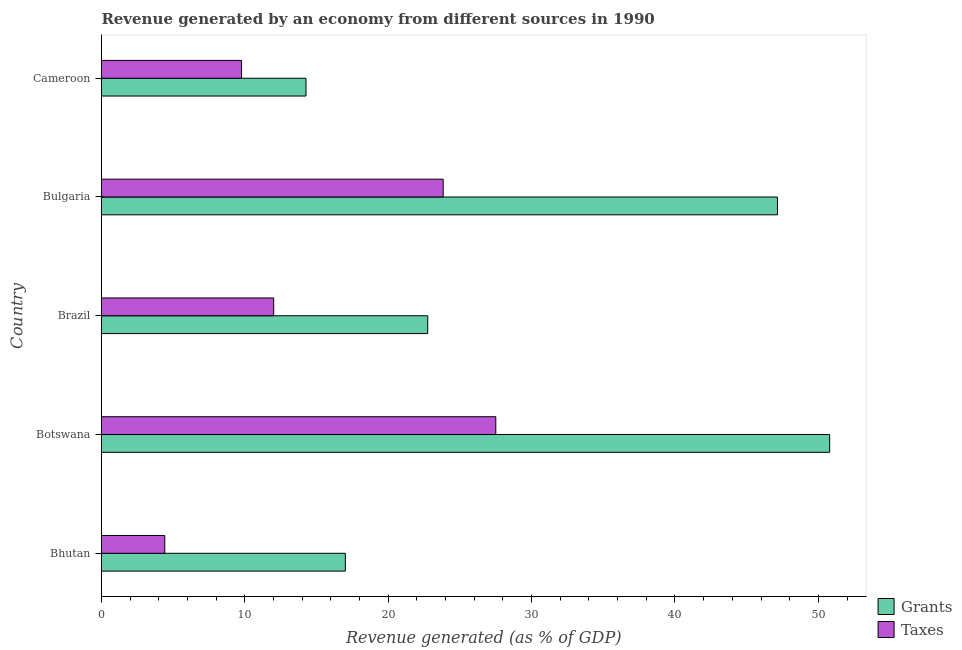How many different coloured bars are there?
Your response must be concise. 2. How many groups of bars are there?
Offer a terse response. 5. Are the number of bars per tick equal to the number of legend labels?
Ensure brevity in your answer.  Yes. How many bars are there on the 5th tick from the top?
Your answer should be compact. 2. What is the label of the 5th group of bars from the top?
Your response must be concise. Bhutan. What is the revenue generated by grants in Bhutan?
Make the answer very short. 17.01. Across all countries, what is the maximum revenue generated by taxes?
Offer a very short reply. 27.5. Across all countries, what is the minimum revenue generated by taxes?
Offer a terse response. 4.41. In which country was the revenue generated by grants maximum?
Provide a succinct answer. Botswana. In which country was the revenue generated by grants minimum?
Your response must be concise. Cameroon. What is the total revenue generated by taxes in the graph?
Your answer should be compact. 77.53. What is the difference between the revenue generated by grants in Botswana and that in Bulgaria?
Offer a terse response. 3.64. What is the difference between the revenue generated by grants in Bulgaria and the revenue generated by taxes in Brazil?
Provide a short and direct response. 35.14. What is the average revenue generated by taxes per country?
Your answer should be very brief. 15.51. What is the difference between the revenue generated by taxes and revenue generated by grants in Brazil?
Ensure brevity in your answer.  -10.74. What is the ratio of the revenue generated by taxes in Brazil to that in Bulgaria?
Your answer should be compact. 0.5. Is the revenue generated by taxes in Bhutan less than that in Cameroon?
Offer a very short reply. Yes. Is the difference between the revenue generated by grants in Bhutan and Bulgaria greater than the difference between the revenue generated by taxes in Bhutan and Bulgaria?
Provide a short and direct response. No. What is the difference between the highest and the second highest revenue generated by taxes?
Your answer should be compact. 3.67. What is the difference between the highest and the lowest revenue generated by grants?
Offer a very short reply. 36.53. In how many countries, is the revenue generated by grants greater than the average revenue generated by grants taken over all countries?
Your answer should be very brief. 2. What does the 2nd bar from the top in Cameroon represents?
Give a very brief answer. Grants. What does the 2nd bar from the bottom in Bulgaria represents?
Provide a short and direct response. Taxes. What is the difference between two consecutive major ticks on the X-axis?
Give a very brief answer. 10. Are the values on the major ticks of X-axis written in scientific E-notation?
Make the answer very short. No. Does the graph contain any zero values?
Make the answer very short. No. Does the graph contain grids?
Make the answer very short. No. What is the title of the graph?
Make the answer very short. Revenue generated by an economy from different sources in 1990. Does "Mineral" appear as one of the legend labels in the graph?
Offer a very short reply. No. What is the label or title of the X-axis?
Give a very brief answer. Revenue generated (as % of GDP). What is the label or title of the Y-axis?
Provide a succinct answer. Country. What is the Revenue generated (as % of GDP) of Grants in Bhutan?
Keep it short and to the point. 17.01. What is the Revenue generated (as % of GDP) in Taxes in Bhutan?
Your response must be concise. 4.41. What is the Revenue generated (as % of GDP) in Grants in Botswana?
Provide a short and direct response. 50.79. What is the Revenue generated (as % of GDP) in Taxes in Botswana?
Offer a terse response. 27.5. What is the Revenue generated (as % of GDP) of Grants in Brazil?
Your response must be concise. 22.75. What is the Revenue generated (as % of GDP) in Taxes in Brazil?
Your response must be concise. 12.01. What is the Revenue generated (as % of GDP) of Grants in Bulgaria?
Provide a short and direct response. 47.15. What is the Revenue generated (as % of GDP) of Taxes in Bulgaria?
Provide a short and direct response. 23.83. What is the Revenue generated (as % of GDP) of Grants in Cameroon?
Your response must be concise. 14.26. What is the Revenue generated (as % of GDP) of Taxes in Cameroon?
Your answer should be very brief. 9.77. Across all countries, what is the maximum Revenue generated (as % of GDP) of Grants?
Make the answer very short. 50.79. Across all countries, what is the maximum Revenue generated (as % of GDP) in Taxes?
Give a very brief answer. 27.5. Across all countries, what is the minimum Revenue generated (as % of GDP) of Grants?
Offer a terse response. 14.26. Across all countries, what is the minimum Revenue generated (as % of GDP) of Taxes?
Make the answer very short. 4.41. What is the total Revenue generated (as % of GDP) in Grants in the graph?
Your answer should be compact. 151.96. What is the total Revenue generated (as % of GDP) of Taxes in the graph?
Your answer should be compact. 77.53. What is the difference between the Revenue generated (as % of GDP) in Grants in Bhutan and that in Botswana?
Make the answer very short. -33.78. What is the difference between the Revenue generated (as % of GDP) of Taxes in Bhutan and that in Botswana?
Keep it short and to the point. -23.09. What is the difference between the Revenue generated (as % of GDP) in Grants in Bhutan and that in Brazil?
Make the answer very short. -5.74. What is the difference between the Revenue generated (as % of GDP) in Taxes in Bhutan and that in Brazil?
Provide a short and direct response. -7.6. What is the difference between the Revenue generated (as % of GDP) in Grants in Bhutan and that in Bulgaria?
Your response must be concise. -30.14. What is the difference between the Revenue generated (as % of GDP) in Taxes in Bhutan and that in Bulgaria?
Ensure brevity in your answer.  -19.42. What is the difference between the Revenue generated (as % of GDP) of Grants in Bhutan and that in Cameroon?
Give a very brief answer. 2.75. What is the difference between the Revenue generated (as % of GDP) of Taxes in Bhutan and that in Cameroon?
Your answer should be compact. -5.35. What is the difference between the Revenue generated (as % of GDP) of Grants in Botswana and that in Brazil?
Ensure brevity in your answer.  28.04. What is the difference between the Revenue generated (as % of GDP) in Taxes in Botswana and that in Brazil?
Offer a terse response. 15.49. What is the difference between the Revenue generated (as % of GDP) of Grants in Botswana and that in Bulgaria?
Make the answer very short. 3.64. What is the difference between the Revenue generated (as % of GDP) of Taxes in Botswana and that in Bulgaria?
Your response must be concise. 3.67. What is the difference between the Revenue generated (as % of GDP) of Grants in Botswana and that in Cameroon?
Keep it short and to the point. 36.53. What is the difference between the Revenue generated (as % of GDP) of Taxes in Botswana and that in Cameroon?
Provide a short and direct response. 17.73. What is the difference between the Revenue generated (as % of GDP) in Grants in Brazil and that in Bulgaria?
Offer a very short reply. -24.39. What is the difference between the Revenue generated (as % of GDP) of Taxes in Brazil and that in Bulgaria?
Provide a short and direct response. -11.82. What is the difference between the Revenue generated (as % of GDP) in Grants in Brazil and that in Cameroon?
Provide a short and direct response. 8.49. What is the difference between the Revenue generated (as % of GDP) of Taxes in Brazil and that in Cameroon?
Ensure brevity in your answer.  2.24. What is the difference between the Revenue generated (as % of GDP) of Grants in Bulgaria and that in Cameroon?
Keep it short and to the point. 32.88. What is the difference between the Revenue generated (as % of GDP) in Taxes in Bulgaria and that in Cameroon?
Your answer should be compact. 14.07. What is the difference between the Revenue generated (as % of GDP) in Grants in Bhutan and the Revenue generated (as % of GDP) in Taxes in Botswana?
Keep it short and to the point. -10.49. What is the difference between the Revenue generated (as % of GDP) in Grants in Bhutan and the Revenue generated (as % of GDP) in Taxes in Brazil?
Keep it short and to the point. 5. What is the difference between the Revenue generated (as % of GDP) of Grants in Bhutan and the Revenue generated (as % of GDP) of Taxes in Bulgaria?
Provide a short and direct response. -6.83. What is the difference between the Revenue generated (as % of GDP) of Grants in Bhutan and the Revenue generated (as % of GDP) of Taxes in Cameroon?
Make the answer very short. 7.24. What is the difference between the Revenue generated (as % of GDP) of Grants in Botswana and the Revenue generated (as % of GDP) of Taxes in Brazil?
Make the answer very short. 38.78. What is the difference between the Revenue generated (as % of GDP) of Grants in Botswana and the Revenue generated (as % of GDP) of Taxes in Bulgaria?
Your answer should be compact. 26.95. What is the difference between the Revenue generated (as % of GDP) in Grants in Botswana and the Revenue generated (as % of GDP) in Taxes in Cameroon?
Your answer should be very brief. 41.02. What is the difference between the Revenue generated (as % of GDP) of Grants in Brazil and the Revenue generated (as % of GDP) of Taxes in Bulgaria?
Your response must be concise. -1.08. What is the difference between the Revenue generated (as % of GDP) of Grants in Brazil and the Revenue generated (as % of GDP) of Taxes in Cameroon?
Give a very brief answer. 12.99. What is the difference between the Revenue generated (as % of GDP) of Grants in Bulgaria and the Revenue generated (as % of GDP) of Taxes in Cameroon?
Ensure brevity in your answer.  37.38. What is the average Revenue generated (as % of GDP) in Grants per country?
Provide a succinct answer. 30.39. What is the average Revenue generated (as % of GDP) in Taxes per country?
Your answer should be compact. 15.51. What is the difference between the Revenue generated (as % of GDP) of Grants and Revenue generated (as % of GDP) of Taxes in Bhutan?
Ensure brevity in your answer.  12.59. What is the difference between the Revenue generated (as % of GDP) in Grants and Revenue generated (as % of GDP) in Taxes in Botswana?
Your response must be concise. 23.29. What is the difference between the Revenue generated (as % of GDP) in Grants and Revenue generated (as % of GDP) in Taxes in Brazil?
Provide a succinct answer. 10.74. What is the difference between the Revenue generated (as % of GDP) in Grants and Revenue generated (as % of GDP) in Taxes in Bulgaria?
Your answer should be compact. 23.31. What is the difference between the Revenue generated (as % of GDP) in Grants and Revenue generated (as % of GDP) in Taxes in Cameroon?
Provide a short and direct response. 4.49. What is the ratio of the Revenue generated (as % of GDP) in Grants in Bhutan to that in Botswana?
Ensure brevity in your answer.  0.33. What is the ratio of the Revenue generated (as % of GDP) in Taxes in Bhutan to that in Botswana?
Keep it short and to the point. 0.16. What is the ratio of the Revenue generated (as % of GDP) in Grants in Bhutan to that in Brazil?
Offer a terse response. 0.75. What is the ratio of the Revenue generated (as % of GDP) in Taxes in Bhutan to that in Brazil?
Your answer should be compact. 0.37. What is the ratio of the Revenue generated (as % of GDP) in Grants in Bhutan to that in Bulgaria?
Offer a very short reply. 0.36. What is the ratio of the Revenue generated (as % of GDP) in Taxes in Bhutan to that in Bulgaria?
Ensure brevity in your answer.  0.19. What is the ratio of the Revenue generated (as % of GDP) in Grants in Bhutan to that in Cameroon?
Your response must be concise. 1.19. What is the ratio of the Revenue generated (as % of GDP) of Taxes in Bhutan to that in Cameroon?
Ensure brevity in your answer.  0.45. What is the ratio of the Revenue generated (as % of GDP) of Grants in Botswana to that in Brazil?
Give a very brief answer. 2.23. What is the ratio of the Revenue generated (as % of GDP) in Taxes in Botswana to that in Brazil?
Your response must be concise. 2.29. What is the ratio of the Revenue generated (as % of GDP) in Grants in Botswana to that in Bulgaria?
Keep it short and to the point. 1.08. What is the ratio of the Revenue generated (as % of GDP) in Taxes in Botswana to that in Bulgaria?
Make the answer very short. 1.15. What is the ratio of the Revenue generated (as % of GDP) of Grants in Botswana to that in Cameroon?
Your answer should be compact. 3.56. What is the ratio of the Revenue generated (as % of GDP) of Taxes in Botswana to that in Cameroon?
Provide a short and direct response. 2.82. What is the ratio of the Revenue generated (as % of GDP) of Grants in Brazil to that in Bulgaria?
Ensure brevity in your answer.  0.48. What is the ratio of the Revenue generated (as % of GDP) of Taxes in Brazil to that in Bulgaria?
Provide a succinct answer. 0.5. What is the ratio of the Revenue generated (as % of GDP) of Grants in Brazil to that in Cameroon?
Your answer should be compact. 1.6. What is the ratio of the Revenue generated (as % of GDP) in Taxes in Brazil to that in Cameroon?
Your response must be concise. 1.23. What is the ratio of the Revenue generated (as % of GDP) of Grants in Bulgaria to that in Cameroon?
Offer a terse response. 3.31. What is the ratio of the Revenue generated (as % of GDP) in Taxes in Bulgaria to that in Cameroon?
Your response must be concise. 2.44. What is the difference between the highest and the second highest Revenue generated (as % of GDP) in Grants?
Keep it short and to the point. 3.64. What is the difference between the highest and the second highest Revenue generated (as % of GDP) in Taxes?
Make the answer very short. 3.67. What is the difference between the highest and the lowest Revenue generated (as % of GDP) in Grants?
Ensure brevity in your answer.  36.53. What is the difference between the highest and the lowest Revenue generated (as % of GDP) of Taxes?
Your answer should be very brief. 23.09. 